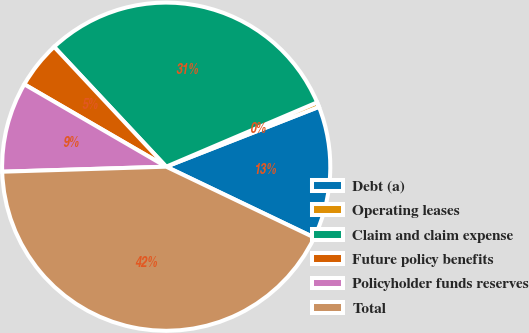Convert chart. <chart><loc_0><loc_0><loc_500><loc_500><pie_chart><fcel>Debt (a)<fcel>Operating leases<fcel>Claim and claim expense<fcel>Future policy benefits<fcel>Policyholder funds reserves<fcel>Total<nl><fcel>13.05%<fcel>0.47%<fcel>30.56%<fcel>4.66%<fcel>8.86%<fcel>42.41%<nl></chart> 